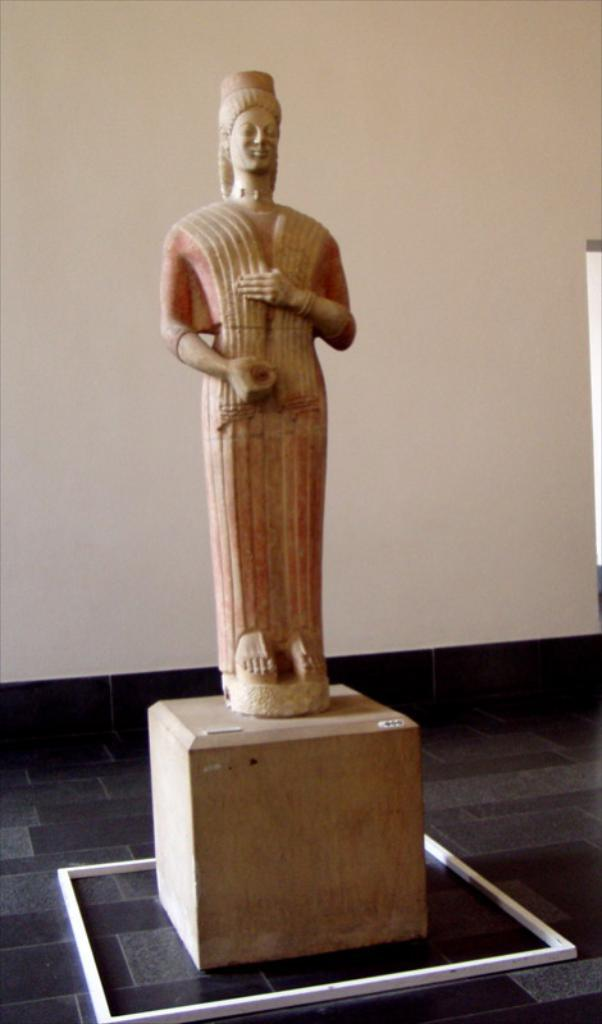What is the main subject in the center of the image? There is a statue in the center of the image. Is the statue elevated in any way? Yes, the statue is on a pedestal. What can be seen in the background of the image? There is a wall in the background of the image. What role does the actor play in the image? There is no actor present in the image; it features a statue on a pedestal with a wall in the background. What type of root can be seen growing from the statue in the image? There are no roots visible in the image, as it features a statue on a pedestal with a wall in the background. 